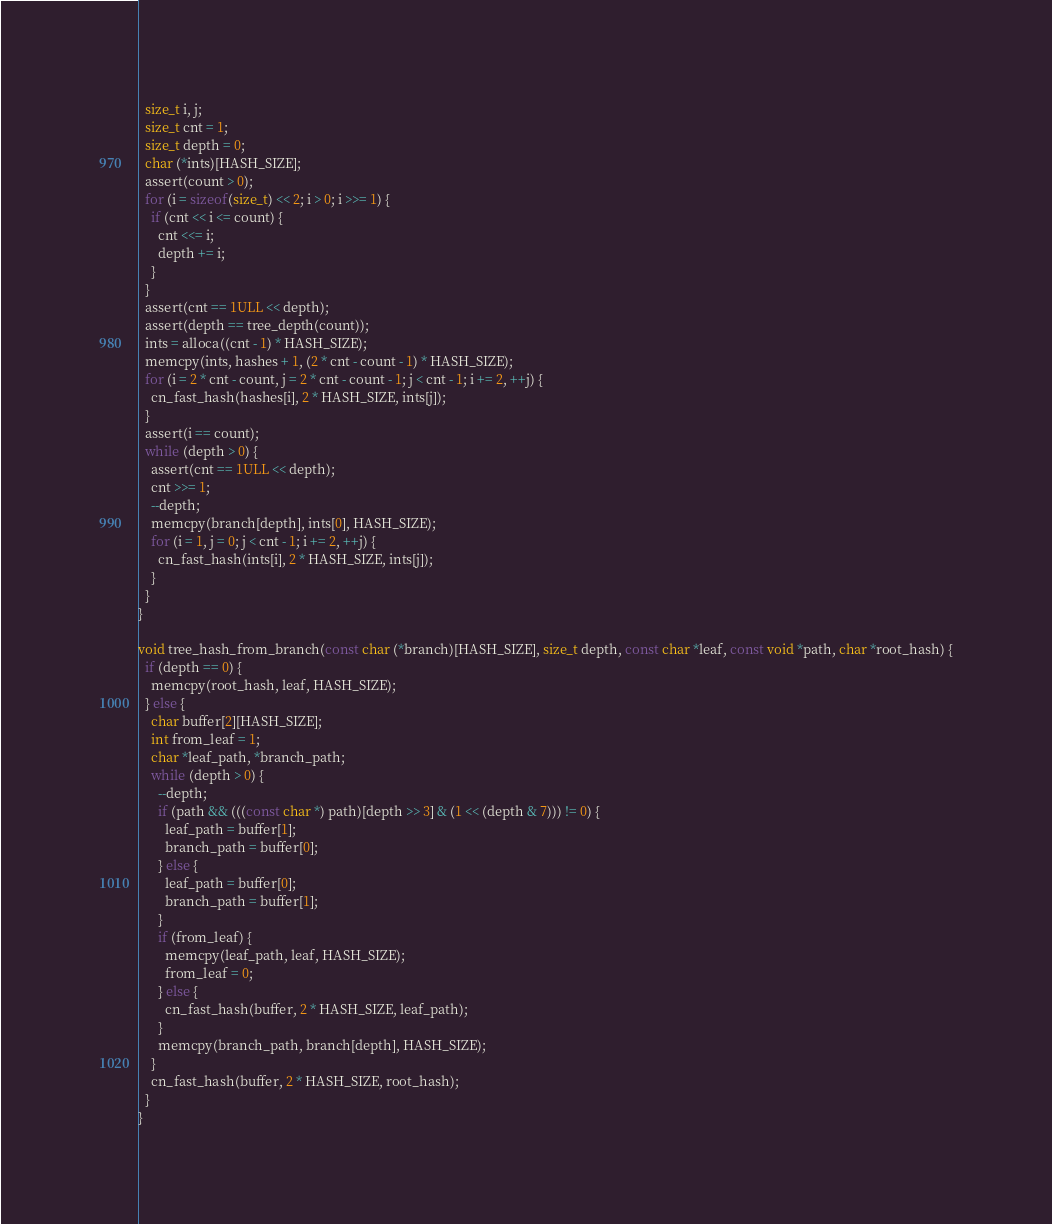Convert code to text. <code><loc_0><loc_0><loc_500><loc_500><_C_>  size_t i, j;
  size_t cnt = 1;
  size_t depth = 0;
  char (*ints)[HASH_SIZE];
  assert(count > 0);
  for (i = sizeof(size_t) << 2; i > 0; i >>= 1) {
    if (cnt << i <= count) {
      cnt <<= i;
      depth += i;
    }
  }
  assert(cnt == 1ULL << depth);
  assert(depth == tree_depth(count));
  ints = alloca((cnt - 1) * HASH_SIZE);
  memcpy(ints, hashes + 1, (2 * cnt - count - 1) * HASH_SIZE);
  for (i = 2 * cnt - count, j = 2 * cnt - count - 1; j < cnt - 1; i += 2, ++j) {
    cn_fast_hash(hashes[i], 2 * HASH_SIZE, ints[j]);
  }
  assert(i == count);
  while (depth > 0) {
    assert(cnt == 1ULL << depth);
    cnt >>= 1;
    --depth;
    memcpy(branch[depth], ints[0], HASH_SIZE);
    for (i = 1, j = 0; j < cnt - 1; i += 2, ++j) {
      cn_fast_hash(ints[i], 2 * HASH_SIZE, ints[j]);
    }
  }
}

void tree_hash_from_branch(const char (*branch)[HASH_SIZE], size_t depth, const char *leaf, const void *path, char *root_hash) {
  if (depth == 0) {
    memcpy(root_hash, leaf, HASH_SIZE);
  } else {
    char buffer[2][HASH_SIZE];
    int from_leaf = 1;
    char *leaf_path, *branch_path;
    while (depth > 0) {
      --depth;
      if (path && (((const char *) path)[depth >> 3] & (1 << (depth & 7))) != 0) {
        leaf_path = buffer[1];
        branch_path = buffer[0];
      } else {
        leaf_path = buffer[0];
        branch_path = buffer[1];
      }
      if (from_leaf) {
        memcpy(leaf_path, leaf, HASH_SIZE);
        from_leaf = 0;
      } else {
        cn_fast_hash(buffer, 2 * HASH_SIZE, leaf_path);
      }
      memcpy(branch_path, branch[depth], HASH_SIZE);
    }
    cn_fast_hash(buffer, 2 * HASH_SIZE, root_hash);
  }
}
</code> 